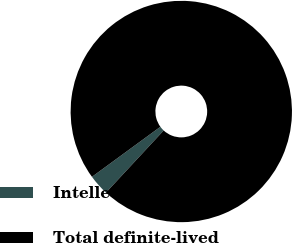<chart> <loc_0><loc_0><loc_500><loc_500><pie_chart><fcel>Intellectual property<fcel>Total definite-lived<nl><fcel>3.04%<fcel>96.96%<nl></chart> 